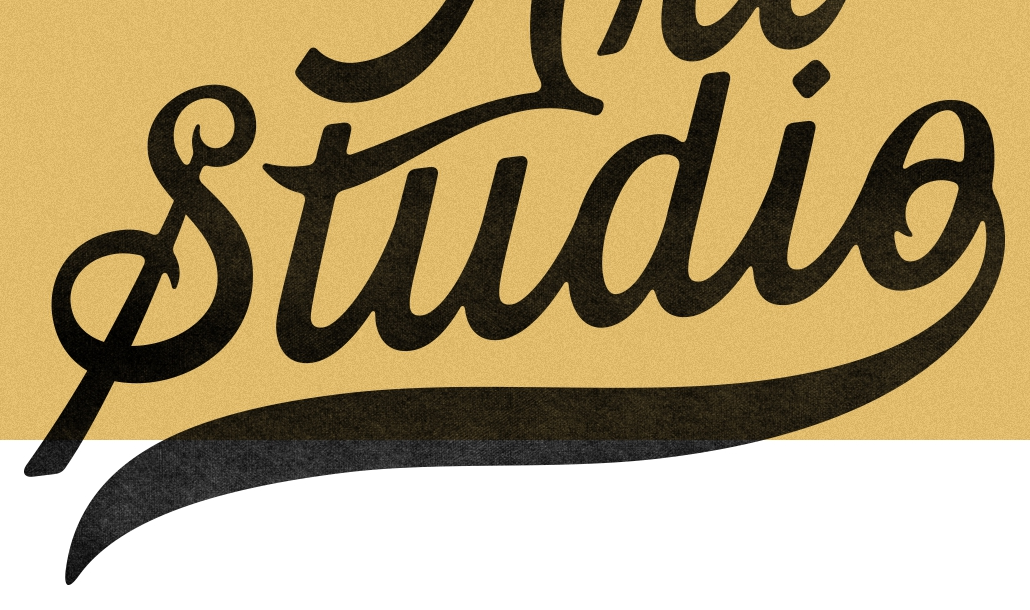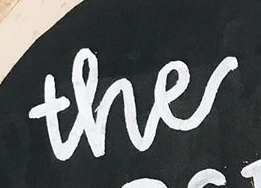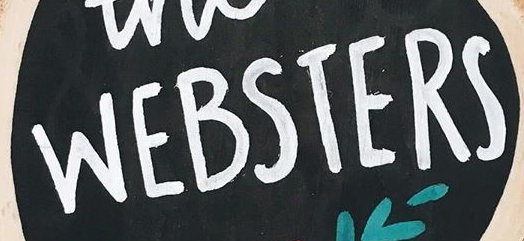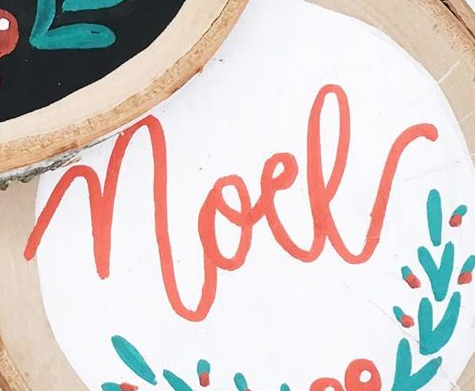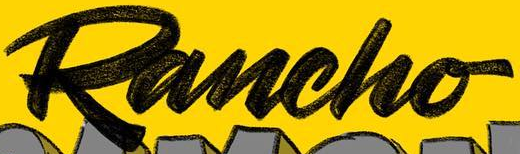What text appears in these images from left to right, separated by a semicolon? Studio; the; WEBSTERS; noel; Rancho 